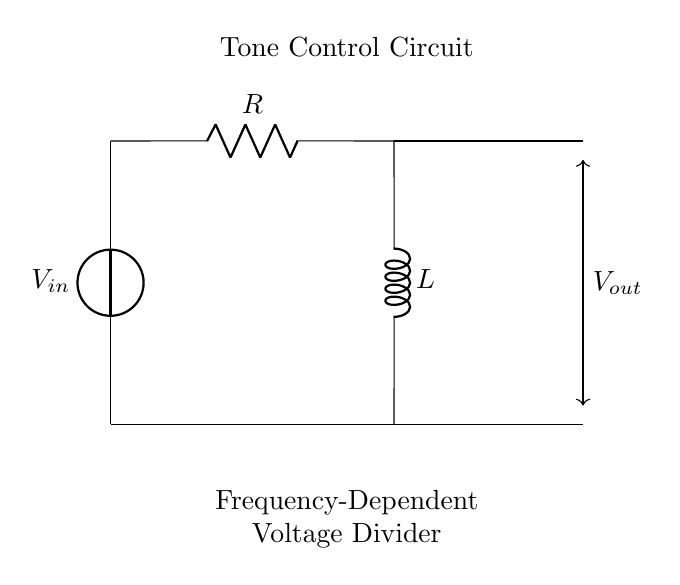What is the input voltage source labeled as? The input voltage source is labeled as V_in, indicating the voltage applied to the circuit.
Answer: V_in What is the value of the component connected vertically on the left? The vertical component on the left is a voltage source, denoted as V_in, which supplies power to the circuit.
Answer: Voltage source What does the resistor component represent in this circuit? The resistor is represented by R, which primarily governs the resistance in the circuit and impacts the voltage division.
Answer: R What does the output voltage depend on in this frequency-dependent divider? The output voltage V_out depends on the combination of the resistor and inductor values and the frequency of the input signal, which affects the impedance.
Answer: Resistor and inductor values How does increasing the frequency affect the output voltage? Increasing the frequency decreases the impedance of the inductor, leading to more voltage drop across the resistor and reducing V_out.
Answer: Reduces V_out What type of circuit is depicted here? This circuit is a frequency-dependent voltage divider circuit, specifically designed for tone control in electronic musical instruments.
Answer: Voltage divider circuit 